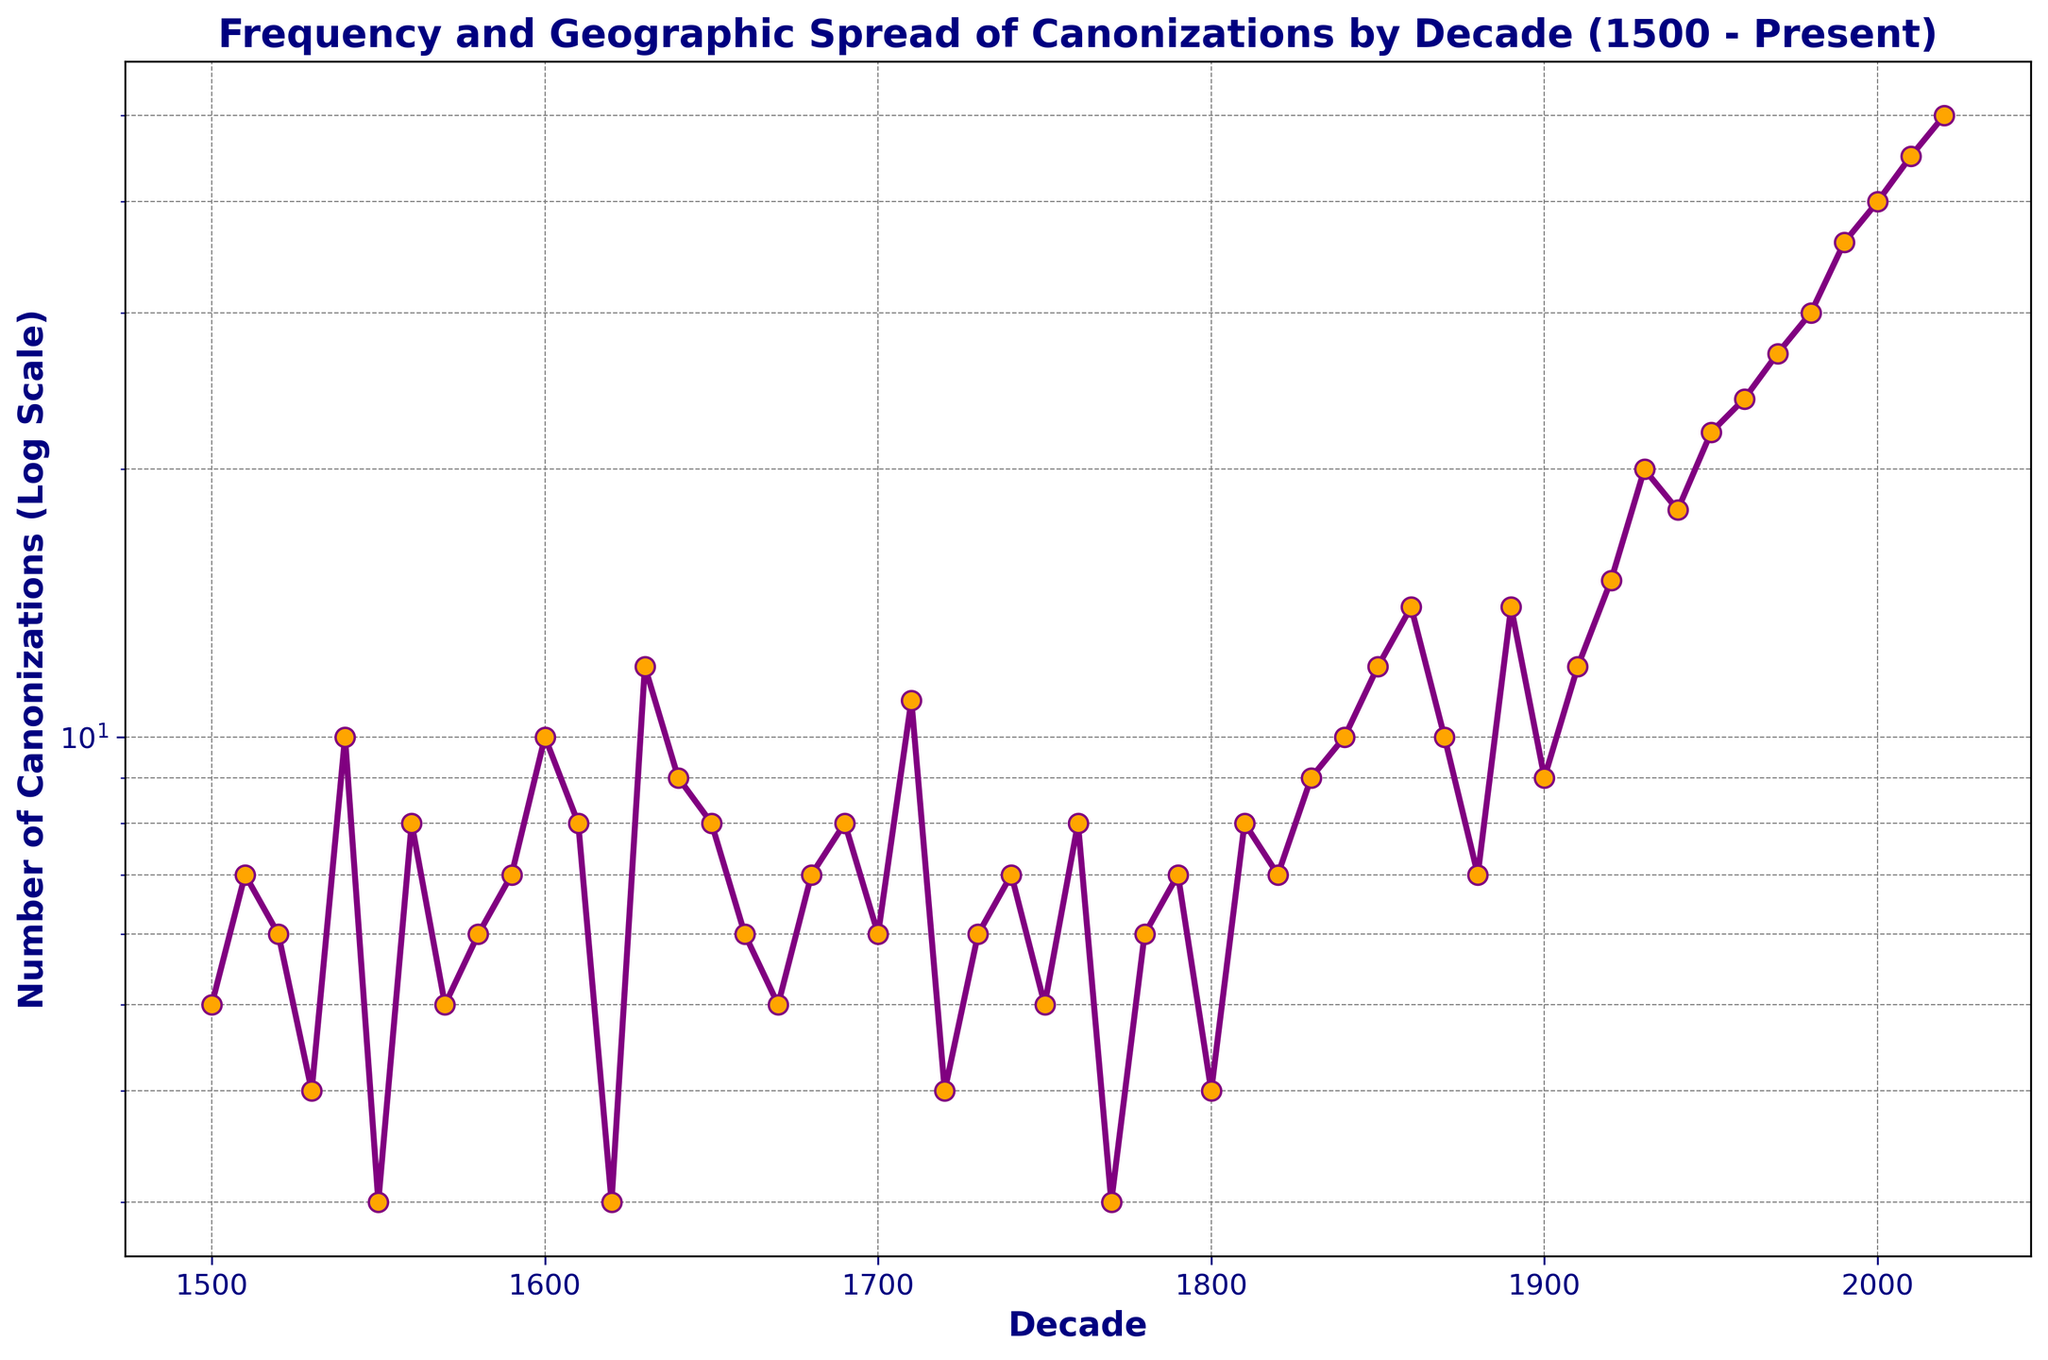What is the highest number of canonizations recorded in a single decade? The highest number of canonizations can be determined by looking for the peak value in the data plot, which occurs in the most recent decades. The peak value is at 2020 with 50 canonizations.
Answer: 50 Between which two consecutive decades did the number of canonizations increase the most? To determine the largest increase between consecutive decades, calculate the difference in the number of canonizations between each pair of consecutive decades. The largest increase is between 1980 (30) and 1990 (36), an increase of 6.
Answer: 1980 and 1990 How does the trend in canonizations change from the 1500s to the present? To observe the trend over time, note the pattern of the data points on the logscale y-axis. There is a gradual increase from the 1500s up until 1600s with fluctuations, followed by a sharp rise starting from 1900 to the present. This suggests an overall upward trend, particularly accelerating in the 20th and 21st centuries.
Answer: Upward trend with acceleration in the recent decades Which decade had a number of canonizations closest to 10? Identify the decades where the data point is closest to 10 canonizations. The 1540s, 1600s, and 1870s all had exactly 10 canonizations.
Answer: 1540, 1600, 1870 What are the general trends in the intervals 1500-1700 and 1800-2020? To analyze these intervals, compare the number of canonizations within each range. From 1500-1700, the data fluctuates without a clear increasing or decreasing trend. From 1800-2020, there is a significant increase, especially post-1900, indicating a rising trend.
Answer: 1500-1700: fluctuating, 1800-2020: increasing How many decades experienced a doubling in the number of canonizations compared to the previous decade? Check each decade to see if the number of canonizations is at least twice that of the previous decade. Decades with a doubling include: 1860 compared to 1850 (14 vs. 12) and 1920 compared to 1910 (15 vs 12).
Answer: 2 Which decade saw the first instance of canonizations exceeding 20? To find the first decade exceeding 20 canonizations, look for the first data point above 20. This occurs in the 1950s with 22 canonizations.
Answer: 1950s What is the difference in the number of canonizations between the decade with the maximum and the decade with the minimum canonizations? The decade with the maximum is 2020 (50 canonizations) and the one with the minimum is 1550 (3 canonizations). The difference is 50 - 3 = 47.
Answer: 47 How does the number of canonizations in the 18th century (1700-1790) compare with those in the 19th century (1800-1890)? Sum the canonizations for each century: 18th century (1700-1790): 6+11+4+6+7+5+8+3+6+7 = 63 and 19th century (1800-1890): 4+8+7+9+10+12+14+10+7+14 = 95. The 19th century had more canonizations.
Answer: 95 in the 19th century, 63 in the 18th century When did the number of canonizations first reach double figures? Identify the decade when canonizations first hit 10 or more. This occurs in the 1540s with exactly 10 canonizations.
Answer: 1540s 